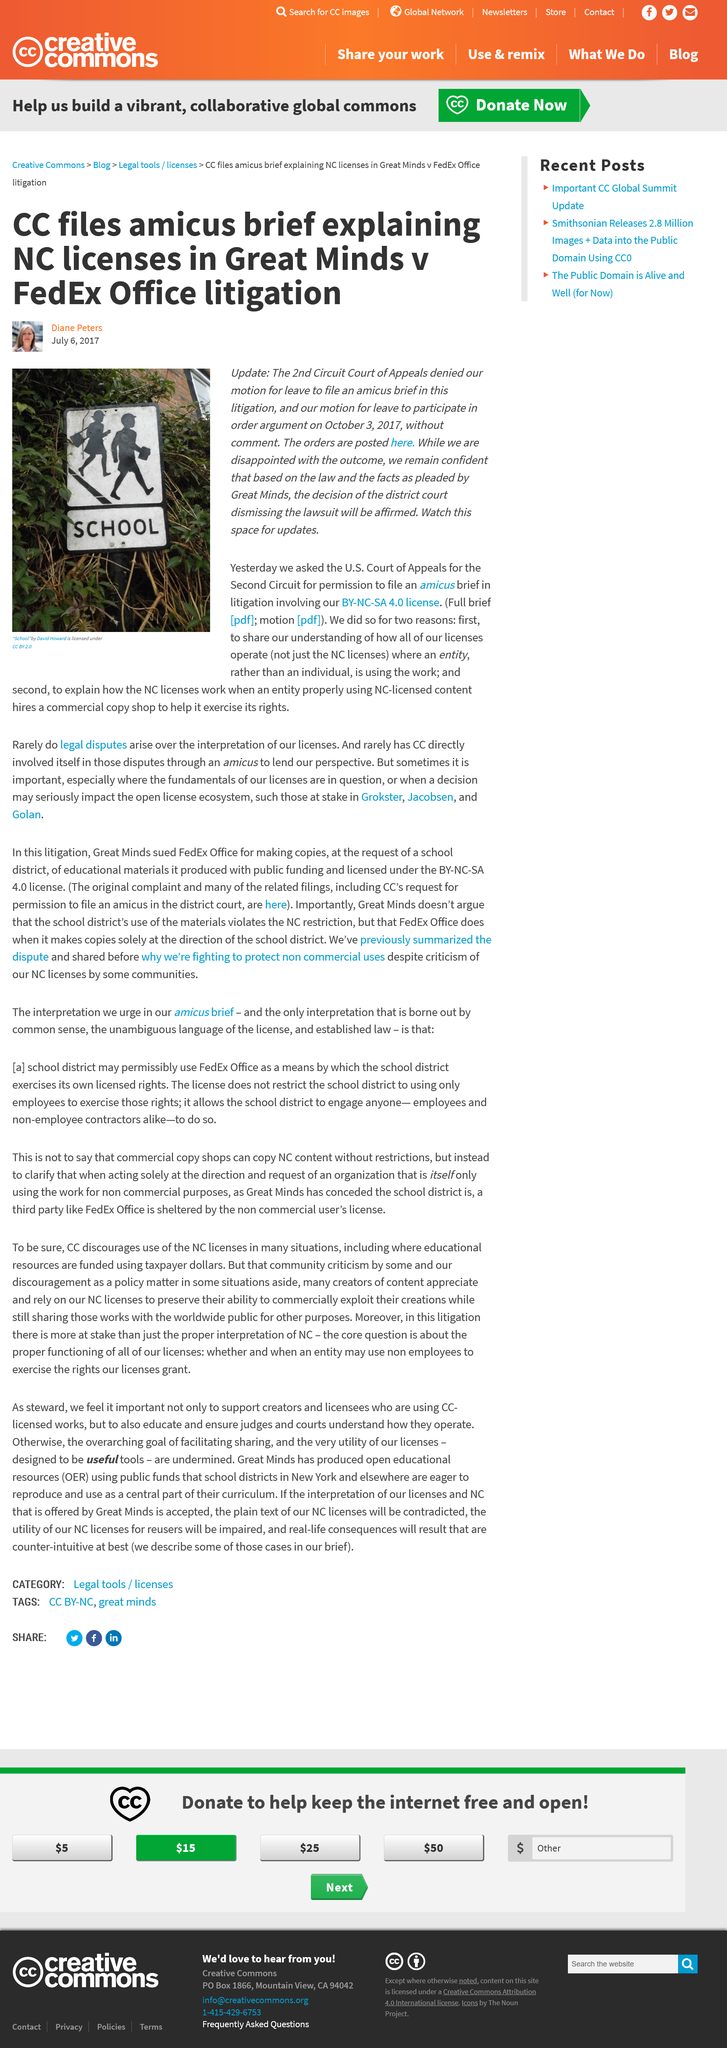Point out several critical features in this image. The author of the article is Diane Peters. The Second Circuit Court of Appeals denied the motion to file an amicus brief in the Great minds v Fedex office litigation. CC filed an amicus brief in the Great Minds v Fedex Office litigation. 